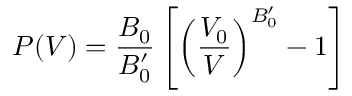<formula> <loc_0><loc_0><loc_500><loc_500>P ( V ) = \frac { B _ { 0 } } { B _ { 0 } ^ { \prime } } \left [ \left ( \frac { V _ { 0 } } { V } \right ) ^ { B _ { 0 } ^ { \prime } } - 1 \right ]</formula> 